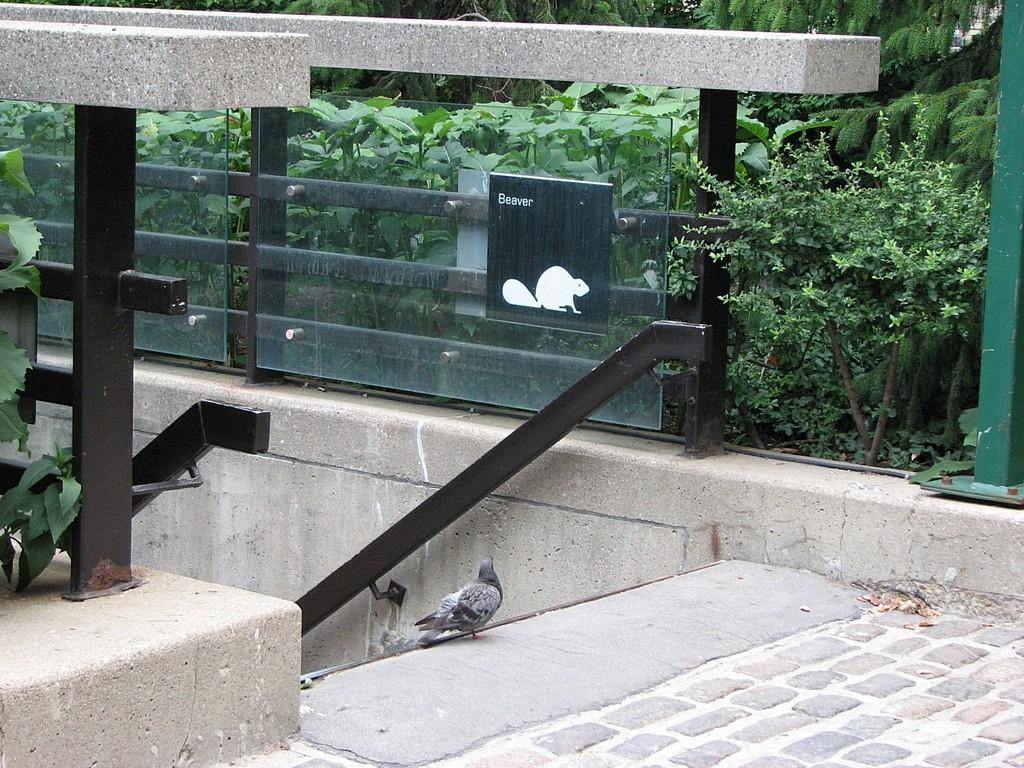How would you summarize this image in a sentence or two? In this image at the bottom there is one pigeon on a walkway, and there is a railing and some plants and a wall. 